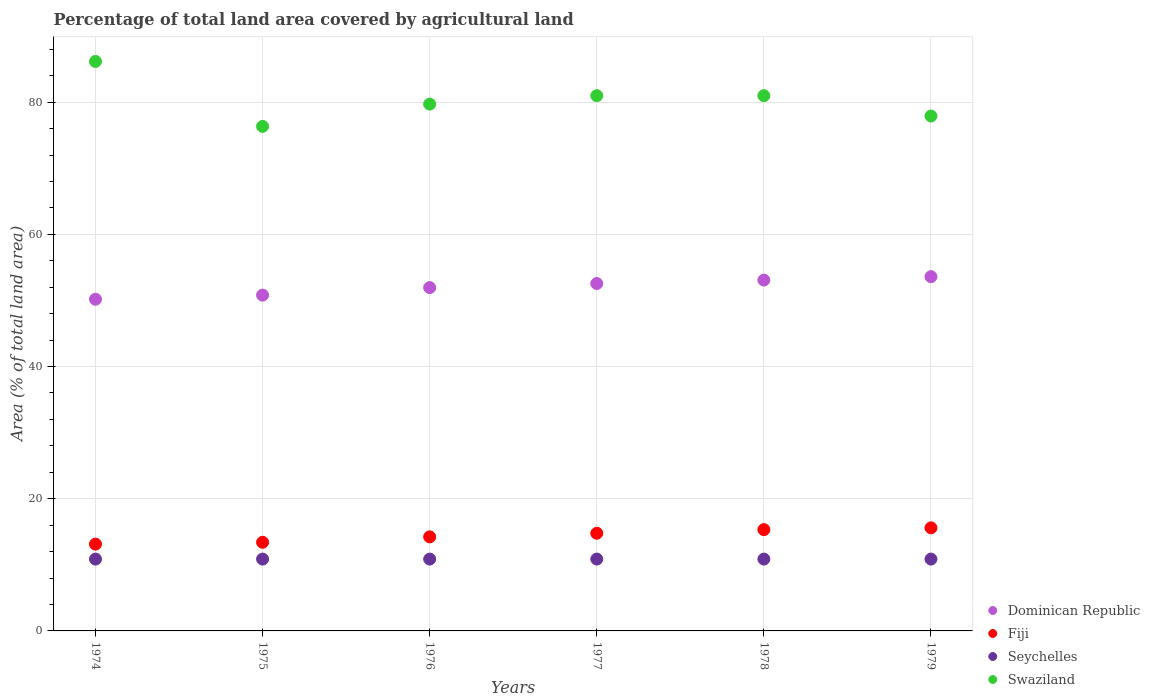How many different coloured dotlines are there?
Ensure brevity in your answer.  4. Is the number of dotlines equal to the number of legend labels?
Give a very brief answer. Yes. What is the percentage of agricultural land in Swaziland in 1976?
Offer a terse response. 79.71. Across all years, what is the maximum percentage of agricultural land in Swaziland?
Provide a short and direct response. 86.16. Across all years, what is the minimum percentage of agricultural land in Swaziland?
Offer a very short reply. 76.34. In which year was the percentage of agricultural land in Dominican Republic maximum?
Offer a very short reply. 1979. In which year was the percentage of agricultural land in Seychelles minimum?
Offer a terse response. 1974. What is the total percentage of agricultural land in Fiji in the graph?
Ensure brevity in your answer.  86.48. What is the difference between the percentage of agricultural land in Swaziland in 1977 and that in 1979?
Provide a succinct answer. 3.08. What is the difference between the percentage of agricultural land in Swaziland in 1974 and the percentage of agricultural land in Seychelles in 1977?
Provide a short and direct response. 75.29. What is the average percentage of agricultural land in Fiji per year?
Give a very brief answer. 14.41. In the year 1977, what is the difference between the percentage of agricultural land in Swaziland and percentage of agricultural land in Fiji?
Make the answer very short. 66.21. In how many years, is the percentage of agricultural land in Seychelles greater than 16 %?
Provide a succinct answer. 0. What is the difference between the highest and the second highest percentage of agricultural land in Swaziland?
Make the answer very short. 5.17. What is the difference between the highest and the lowest percentage of agricultural land in Dominican Republic?
Provide a short and direct response. 3.41. Does the percentage of agricultural land in Fiji monotonically increase over the years?
Ensure brevity in your answer.  Yes. Is the percentage of agricultural land in Seychelles strictly greater than the percentage of agricultural land in Dominican Republic over the years?
Your answer should be compact. No. Is the percentage of agricultural land in Dominican Republic strictly less than the percentage of agricultural land in Fiji over the years?
Keep it short and to the point. No. What is the difference between two consecutive major ticks on the Y-axis?
Your answer should be compact. 20. Are the values on the major ticks of Y-axis written in scientific E-notation?
Give a very brief answer. No. How are the legend labels stacked?
Offer a very short reply. Vertical. What is the title of the graph?
Keep it short and to the point. Percentage of total land area covered by agricultural land. Does "Japan" appear as one of the legend labels in the graph?
Make the answer very short. No. What is the label or title of the X-axis?
Provide a short and direct response. Years. What is the label or title of the Y-axis?
Keep it short and to the point. Area (% of total land area). What is the Area (% of total land area) in Dominican Republic in 1974?
Your response must be concise. 50.19. What is the Area (% of total land area) of Fiji in 1974?
Provide a succinct answer. 13.14. What is the Area (% of total land area) of Seychelles in 1974?
Give a very brief answer. 10.87. What is the Area (% of total land area) of Swaziland in 1974?
Ensure brevity in your answer.  86.16. What is the Area (% of total land area) in Dominican Republic in 1975?
Give a very brief answer. 50.81. What is the Area (% of total land area) of Fiji in 1975?
Offer a very short reply. 13.41. What is the Area (% of total land area) in Seychelles in 1975?
Keep it short and to the point. 10.87. What is the Area (% of total land area) of Swaziland in 1975?
Make the answer very short. 76.34. What is the Area (% of total land area) of Dominican Republic in 1976?
Offer a terse response. 51.95. What is the Area (% of total land area) of Fiji in 1976?
Give a very brief answer. 14.23. What is the Area (% of total land area) of Seychelles in 1976?
Provide a succinct answer. 10.87. What is the Area (% of total land area) in Swaziland in 1976?
Provide a short and direct response. 79.71. What is the Area (% of total land area) in Dominican Republic in 1977?
Ensure brevity in your answer.  52.57. What is the Area (% of total land area) in Fiji in 1977?
Offer a very short reply. 14.78. What is the Area (% of total land area) of Seychelles in 1977?
Offer a terse response. 10.87. What is the Area (% of total land area) in Swaziland in 1977?
Provide a succinct answer. 80.99. What is the Area (% of total land area) of Dominican Republic in 1978?
Provide a succinct answer. 53.08. What is the Area (% of total land area) of Fiji in 1978?
Make the answer very short. 15.33. What is the Area (% of total land area) in Seychelles in 1978?
Your answer should be compact. 10.87. What is the Area (% of total land area) in Swaziland in 1978?
Your answer should be very brief. 80.99. What is the Area (% of total land area) of Dominican Republic in 1979?
Offer a very short reply. 53.6. What is the Area (% of total land area) of Fiji in 1979?
Ensure brevity in your answer.  15.6. What is the Area (% of total land area) of Seychelles in 1979?
Provide a short and direct response. 10.87. What is the Area (% of total land area) in Swaziland in 1979?
Your response must be concise. 77.91. Across all years, what is the maximum Area (% of total land area) in Dominican Republic?
Your answer should be compact. 53.6. Across all years, what is the maximum Area (% of total land area) of Fiji?
Your response must be concise. 15.6. Across all years, what is the maximum Area (% of total land area) in Seychelles?
Ensure brevity in your answer.  10.87. Across all years, what is the maximum Area (% of total land area) of Swaziland?
Offer a very short reply. 86.16. Across all years, what is the minimum Area (% of total land area) in Dominican Republic?
Your answer should be very brief. 50.19. Across all years, what is the minimum Area (% of total land area) in Fiji?
Your answer should be very brief. 13.14. Across all years, what is the minimum Area (% of total land area) of Seychelles?
Provide a short and direct response. 10.87. Across all years, what is the minimum Area (% of total land area) of Swaziland?
Your response must be concise. 76.34. What is the total Area (% of total land area) in Dominican Republic in the graph?
Provide a succinct answer. 312.19. What is the total Area (% of total land area) in Fiji in the graph?
Your response must be concise. 86.48. What is the total Area (% of total land area) of Seychelles in the graph?
Make the answer very short. 65.22. What is the total Area (% of total land area) of Swaziland in the graph?
Offer a very short reply. 482.09. What is the difference between the Area (% of total land area) of Dominican Republic in 1974 and that in 1975?
Your response must be concise. -0.62. What is the difference between the Area (% of total land area) of Fiji in 1974 and that in 1975?
Give a very brief answer. -0.27. What is the difference between the Area (% of total land area) in Swaziland in 1974 and that in 1975?
Offer a very short reply. 9.83. What is the difference between the Area (% of total land area) of Dominican Republic in 1974 and that in 1976?
Offer a terse response. -1.76. What is the difference between the Area (% of total land area) in Fiji in 1974 and that in 1976?
Ensure brevity in your answer.  -1.09. What is the difference between the Area (% of total land area) in Swaziland in 1974 and that in 1976?
Keep it short and to the point. 6.45. What is the difference between the Area (% of total land area) of Dominican Republic in 1974 and that in 1977?
Ensure brevity in your answer.  -2.38. What is the difference between the Area (% of total land area) of Fiji in 1974 and that in 1977?
Make the answer very short. -1.64. What is the difference between the Area (% of total land area) of Seychelles in 1974 and that in 1977?
Your answer should be compact. 0. What is the difference between the Area (% of total land area) in Swaziland in 1974 and that in 1977?
Give a very brief answer. 5.17. What is the difference between the Area (% of total land area) in Dominican Republic in 1974 and that in 1978?
Your response must be concise. -2.9. What is the difference between the Area (% of total land area) of Fiji in 1974 and that in 1978?
Your answer should be compact. -2.19. What is the difference between the Area (% of total land area) in Seychelles in 1974 and that in 1978?
Your answer should be compact. 0. What is the difference between the Area (% of total land area) of Swaziland in 1974 and that in 1978?
Keep it short and to the point. 5.17. What is the difference between the Area (% of total land area) of Dominican Republic in 1974 and that in 1979?
Your answer should be compact. -3.41. What is the difference between the Area (% of total land area) of Fiji in 1974 and that in 1979?
Make the answer very short. -2.46. What is the difference between the Area (% of total land area) of Seychelles in 1974 and that in 1979?
Provide a succinct answer. 0. What is the difference between the Area (% of total land area) of Swaziland in 1974 and that in 1979?
Keep it short and to the point. 8.26. What is the difference between the Area (% of total land area) of Dominican Republic in 1975 and that in 1976?
Ensure brevity in your answer.  -1.14. What is the difference between the Area (% of total land area) in Fiji in 1975 and that in 1976?
Your answer should be compact. -0.82. What is the difference between the Area (% of total land area) in Seychelles in 1975 and that in 1976?
Ensure brevity in your answer.  0. What is the difference between the Area (% of total land area) of Swaziland in 1975 and that in 1976?
Keep it short and to the point. -3.37. What is the difference between the Area (% of total land area) in Dominican Republic in 1975 and that in 1977?
Your response must be concise. -1.76. What is the difference between the Area (% of total land area) of Fiji in 1975 and that in 1977?
Provide a short and direct response. -1.37. What is the difference between the Area (% of total land area) of Swaziland in 1975 and that in 1977?
Give a very brief answer. -4.65. What is the difference between the Area (% of total land area) of Dominican Republic in 1975 and that in 1978?
Make the answer very short. -2.28. What is the difference between the Area (% of total land area) in Fiji in 1975 and that in 1978?
Keep it short and to the point. -1.92. What is the difference between the Area (% of total land area) of Seychelles in 1975 and that in 1978?
Offer a very short reply. 0. What is the difference between the Area (% of total land area) of Swaziland in 1975 and that in 1978?
Your answer should be very brief. -4.65. What is the difference between the Area (% of total land area) of Dominican Republic in 1975 and that in 1979?
Offer a terse response. -2.79. What is the difference between the Area (% of total land area) in Fiji in 1975 and that in 1979?
Keep it short and to the point. -2.19. What is the difference between the Area (% of total land area) in Swaziland in 1975 and that in 1979?
Your answer should be very brief. -1.57. What is the difference between the Area (% of total land area) of Dominican Republic in 1976 and that in 1977?
Your answer should be compact. -0.62. What is the difference between the Area (% of total land area) in Fiji in 1976 and that in 1977?
Make the answer very short. -0.55. What is the difference between the Area (% of total land area) of Swaziland in 1976 and that in 1977?
Your answer should be very brief. -1.28. What is the difference between the Area (% of total land area) of Dominican Republic in 1976 and that in 1978?
Your answer should be compact. -1.14. What is the difference between the Area (% of total land area) in Fiji in 1976 and that in 1978?
Ensure brevity in your answer.  -1.09. What is the difference between the Area (% of total land area) in Seychelles in 1976 and that in 1978?
Make the answer very short. 0. What is the difference between the Area (% of total land area) of Swaziland in 1976 and that in 1978?
Give a very brief answer. -1.28. What is the difference between the Area (% of total land area) of Dominican Republic in 1976 and that in 1979?
Your response must be concise. -1.66. What is the difference between the Area (% of total land area) of Fiji in 1976 and that in 1979?
Your answer should be compact. -1.37. What is the difference between the Area (% of total land area) in Seychelles in 1976 and that in 1979?
Keep it short and to the point. 0. What is the difference between the Area (% of total land area) of Swaziland in 1976 and that in 1979?
Make the answer very short. 1.8. What is the difference between the Area (% of total land area) in Dominican Republic in 1977 and that in 1978?
Provide a succinct answer. -0.52. What is the difference between the Area (% of total land area) in Fiji in 1977 and that in 1978?
Make the answer very short. -0.55. What is the difference between the Area (% of total land area) of Seychelles in 1977 and that in 1978?
Give a very brief answer. 0. What is the difference between the Area (% of total land area) in Dominican Republic in 1977 and that in 1979?
Offer a terse response. -1.03. What is the difference between the Area (% of total land area) in Fiji in 1977 and that in 1979?
Ensure brevity in your answer.  -0.82. What is the difference between the Area (% of total land area) of Swaziland in 1977 and that in 1979?
Provide a short and direct response. 3.08. What is the difference between the Area (% of total land area) in Dominican Republic in 1978 and that in 1979?
Offer a very short reply. -0.52. What is the difference between the Area (% of total land area) of Fiji in 1978 and that in 1979?
Offer a very short reply. -0.27. What is the difference between the Area (% of total land area) in Swaziland in 1978 and that in 1979?
Provide a short and direct response. 3.08. What is the difference between the Area (% of total land area) of Dominican Republic in 1974 and the Area (% of total land area) of Fiji in 1975?
Make the answer very short. 36.78. What is the difference between the Area (% of total land area) in Dominican Republic in 1974 and the Area (% of total land area) in Seychelles in 1975?
Provide a short and direct response. 39.32. What is the difference between the Area (% of total land area) in Dominican Republic in 1974 and the Area (% of total land area) in Swaziland in 1975?
Your answer should be compact. -26.15. What is the difference between the Area (% of total land area) in Fiji in 1974 and the Area (% of total land area) in Seychelles in 1975?
Your response must be concise. 2.27. What is the difference between the Area (% of total land area) in Fiji in 1974 and the Area (% of total land area) in Swaziland in 1975?
Your response must be concise. -63.2. What is the difference between the Area (% of total land area) of Seychelles in 1974 and the Area (% of total land area) of Swaziland in 1975?
Give a very brief answer. -65.47. What is the difference between the Area (% of total land area) in Dominican Republic in 1974 and the Area (% of total land area) in Fiji in 1976?
Ensure brevity in your answer.  35.96. What is the difference between the Area (% of total land area) in Dominican Republic in 1974 and the Area (% of total land area) in Seychelles in 1976?
Offer a terse response. 39.32. What is the difference between the Area (% of total land area) of Dominican Republic in 1974 and the Area (% of total land area) of Swaziland in 1976?
Your answer should be compact. -29.52. What is the difference between the Area (% of total land area) of Fiji in 1974 and the Area (% of total land area) of Seychelles in 1976?
Provide a short and direct response. 2.27. What is the difference between the Area (% of total land area) in Fiji in 1974 and the Area (% of total land area) in Swaziland in 1976?
Offer a terse response. -66.57. What is the difference between the Area (% of total land area) in Seychelles in 1974 and the Area (% of total land area) in Swaziland in 1976?
Ensure brevity in your answer.  -68.84. What is the difference between the Area (% of total land area) of Dominican Republic in 1974 and the Area (% of total land area) of Fiji in 1977?
Your answer should be compact. 35.41. What is the difference between the Area (% of total land area) in Dominican Republic in 1974 and the Area (% of total land area) in Seychelles in 1977?
Ensure brevity in your answer.  39.32. What is the difference between the Area (% of total land area) of Dominican Republic in 1974 and the Area (% of total land area) of Swaziland in 1977?
Make the answer very short. -30.8. What is the difference between the Area (% of total land area) in Fiji in 1974 and the Area (% of total land area) in Seychelles in 1977?
Make the answer very short. 2.27. What is the difference between the Area (% of total land area) of Fiji in 1974 and the Area (% of total land area) of Swaziland in 1977?
Your response must be concise. -67.85. What is the difference between the Area (% of total land area) of Seychelles in 1974 and the Area (% of total land area) of Swaziland in 1977?
Offer a terse response. -70.12. What is the difference between the Area (% of total land area) of Dominican Republic in 1974 and the Area (% of total land area) of Fiji in 1978?
Your answer should be very brief. 34.86. What is the difference between the Area (% of total land area) in Dominican Republic in 1974 and the Area (% of total land area) in Seychelles in 1978?
Ensure brevity in your answer.  39.32. What is the difference between the Area (% of total land area) of Dominican Republic in 1974 and the Area (% of total land area) of Swaziland in 1978?
Offer a terse response. -30.8. What is the difference between the Area (% of total land area) of Fiji in 1974 and the Area (% of total land area) of Seychelles in 1978?
Your response must be concise. 2.27. What is the difference between the Area (% of total land area) in Fiji in 1974 and the Area (% of total land area) in Swaziland in 1978?
Offer a very short reply. -67.85. What is the difference between the Area (% of total land area) in Seychelles in 1974 and the Area (% of total land area) in Swaziland in 1978?
Provide a short and direct response. -70.12. What is the difference between the Area (% of total land area) of Dominican Republic in 1974 and the Area (% of total land area) of Fiji in 1979?
Ensure brevity in your answer.  34.59. What is the difference between the Area (% of total land area) of Dominican Republic in 1974 and the Area (% of total land area) of Seychelles in 1979?
Make the answer very short. 39.32. What is the difference between the Area (% of total land area) in Dominican Republic in 1974 and the Area (% of total land area) in Swaziland in 1979?
Give a very brief answer. -27.72. What is the difference between the Area (% of total land area) of Fiji in 1974 and the Area (% of total land area) of Seychelles in 1979?
Your answer should be compact. 2.27. What is the difference between the Area (% of total land area) in Fiji in 1974 and the Area (% of total land area) in Swaziland in 1979?
Ensure brevity in your answer.  -64.77. What is the difference between the Area (% of total land area) of Seychelles in 1974 and the Area (% of total land area) of Swaziland in 1979?
Your response must be concise. -67.04. What is the difference between the Area (% of total land area) in Dominican Republic in 1975 and the Area (% of total land area) in Fiji in 1976?
Make the answer very short. 36.58. What is the difference between the Area (% of total land area) of Dominican Republic in 1975 and the Area (% of total land area) of Seychelles in 1976?
Give a very brief answer. 39.94. What is the difference between the Area (% of total land area) in Dominican Republic in 1975 and the Area (% of total land area) in Swaziland in 1976?
Your answer should be compact. -28.9. What is the difference between the Area (% of total land area) in Fiji in 1975 and the Area (% of total land area) in Seychelles in 1976?
Offer a terse response. 2.54. What is the difference between the Area (% of total land area) of Fiji in 1975 and the Area (% of total land area) of Swaziland in 1976?
Provide a succinct answer. -66.3. What is the difference between the Area (% of total land area) in Seychelles in 1975 and the Area (% of total land area) in Swaziland in 1976?
Your answer should be compact. -68.84. What is the difference between the Area (% of total land area) of Dominican Republic in 1975 and the Area (% of total land area) of Fiji in 1977?
Ensure brevity in your answer.  36.03. What is the difference between the Area (% of total land area) in Dominican Republic in 1975 and the Area (% of total land area) in Seychelles in 1977?
Your response must be concise. 39.94. What is the difference between the Area (% of total land area) of Dominican Republic in 1975 and the Area (% of total land area) of Swaziland in 1977?
Your answer should be very brief. -30.18. What is the difference between the Area (% of total land area) in Fiji in 1975 and the Area (% of total land area) in Seychelles in 1977?
Ensure brevity in your answer.  2.54. What is the difference between the Area (% of total land area) of Fiji in 1975 and the Area (% of total land area) of Swaziland in 1977?
Offer a very short reply. -67.58. What is the difference between the Area (% of total land area) of Seychelles in 1975 and the Area (% of total land area) of Swaziland in 1977?
Provide a succinct answer. -70.12. What is the difference between the Area (% of total land area) of Dominican Republic in 1975 and the Area (% of total land area) of Fiji in 1978?
Provide a succinct answer. 35.48. What is the difference between the Area (% of total land area) of Dominican Republic in 1975 and the Area (% of total land area) of Seychelles in 1978?
Ensure brevity in your answer.  39.94. What is the difference between the Area (% of total land area) in Dominican Republic in 1975 and the Area (% of total land area) in Swaziland in 1978?
Provide a short and direct response. -30.18. What is the difference between the Area (% of total land area) in Fiji in 1975 and the Area (% of total land area) in Seychelles in 1978?
Provide a short and direct response. 2.54. What is the difference between the Area (% of total land area) in Fiji in 1975 and the Area (% of total land area) in Swaziland in 1978?
Your answer should be very brief. -67.58. What is the difference between the Area (% of total land area) of Seychelles in 1975 and the Area (% of total land area) of Swaziland in 1978?
Offer a very short reply. -70.12. What is the difference between the Area (% of total land area) of Dominican Republic in 1975 and the Area (% of total land area) of Fiji in 1979?
Give a very brief answer. 35.21. What is the difference between the Area (% of total land area) in Dominican Republic in 1975 and the Area (% of total land area) in Seychelles in 1979?
Your answer should be compact. 39.94. What is the difference between the Area (% of total land area) of Dominican Republic in 1975 and the Area (% of total land area) of Swaziland in 1979?
Offer a very short reply. -27.1. What is the difference between the Area (% of total land area) of Fiji in 1975 and the Area (% of total land area) of Seychelles in 1979?
Keep it short and to the point. 2.54. What is the difference between the Area (% of total land area) in Fiji in 1975 and the Area (% of total land area) in Swaziland in 1979?
Provide a short and direct response. -64.5. What is the difference between the Area (% of total land area) in Seychelles in 1975 and the Area (% of total land area) in Swaziland in 1979?
Keep it short and to the point. -67.04. What is the difference between the Area (% of total land area) in Dominican Republic in 1976 and the Area (% of total land area) in Fiji in 1977?
Keep it short and to the point. 37.17. What is the difference between the Area (% of total land area) of Dominican Republic in 1976 and the Area (% of total land area) of Seychelles in 1977?
Your response must be concise. 41.08. What is the difference between the Area (% of total land area) of Dominican Republic in 1976 and the Area (% of total land area) of Swaziland in 1977?
Your answer should be compact. -29.04. What is the difference between the Area (% of total land area) in Fiji in 1976 and the Area (% of total land area) in Seychelles in 1977?
Ensure brevity in your answer.  3.36. What is the difference between the Area (% of total land area) of Fiji in 1976 and the Area (% of total land area) of Swaziland in 1977?
Offer a terse response. -66.76. What is the difference between the Area (% of total land area) in Seychelles in 1976 and the Area (% of total land area) in Swaziland in 1977?
Give a very brief answer. -70.12. What is the difference between the Area (% of total land area) in Dominican Republic in 1976 and the Area (% of total land area) in Fiji in 1978?
Offer a terse response. 36.62. What is the difference between the Area (% of total land area) of Dominican Republic in 1976 and the Area (% of total land area) of Seychelles in 1978?
Provide a succinct answer. 41.08. What is the difference between the Area (% of total land area) in Dominican Republic in 1976 and the Area (% of total land area) in Swaziland in 1978?
Keep it short and to the point. -29.04. What is the difference between the Area (% of total land area) in Fiji in 1976 and the Area (% of total land area) in Seychelles in 1978?
Give a very brief answer. 3.36. What is the difference between the Area (% of total land area) of Fiji in 1976 and the Area (% of total land area) of Swaziland in 1978?
Your answer should be compact. -66.76. What is the difference between the Area (% of total land area) of Seychelles in 1976 and the Area (% of total land area) of Swaziland in 1978?
Your answer should be very brief. -70.12. What is the difference between the Area (% of total land area) of Dominican Republic in 1976 and the Area (% of total land area) of Fiji in 1979?
Your answer should be compact. 36.35. What is the difference between the Area (% of total land area) of Dominican Republic in 1976 and the Area (% of total land area) of Seychelles in 1979?
Offer a very short reply. 41.08. What is the difference between the Area (% of total land area) of Dominican Republic in 1976 and the Area (% of total land area) of Swaziland in 1979?
Your answer should be compact. -25.96. What is the difference between the Area (% of total land area) in Fiji in 1976 and the Area (% of total land area) in Seychelles in 1979?
Give a very brief answer. 3.36. What is the difference between the Area (% of total land area) of Fiji in 1976 and the Area (% of total land area) of Swaziland in 1979?
Keep it short and to the point. -63.68. What is the difference between the Area (% of total land area) in Seychelles in 1976 and the Area (% of total land area) in Swaziland in 1979?
Offer a very short reply. -67.04. What is the difference between the Area (% of total land area) of Dominican Republic in 1977 and the Area (% of total land area) of Fiji in 1978?
Your response must be concise. 37.24. What is the difference between the Area (% of total land area) in Dominican Republic in 1977 and the Area (% of total land area) in Seychelles in 1978?
Provide a succinct answer. 41.7. What is the difference between the Area (% of total land area) of Dominican Republic in 1977 and the Area (% of total land area) of Swaziland in 1978?
Your answer should be compact. -28.42. What is the difference between the Area (% of total land area) in Fiji in 1977 and the Area (% of total land area) in Seychelles in 1978?
Provide a succinct answer. 3.91. What is the difference between the Area (% of total land area) of Fiji in 1977 and the Area (% of total land area) of Swaziland in 1978?
Give a very brief answer. -66.21. What is the difference between the Area (% of total land area) in Seychelles in 1977 and the Area (% of total land area) in Swaziland in 1978?
Make the answer very short. -70.12. What is the difference between the Area (% of total land area) of Dominican Republic in 1977 and the Area (% of total land area) of Fiji in 1979?
Offer a very short reply. 36.97. What is the difference between the Area (% of total land area) of Dominican Republic in 1977 and the Area (% of total land area) of Seychelles in 1979?
Provide a short and direct response. 41.7. What is the difference between the Area (% of total land area) of Dominican Republic in 1977 and the Area (% of total land area) of Swaziland in 1979?
Make the answer very short. -25.34. What is the difference between the Area (% of total land area) in Fiji in 1977 and the Area (% of total land area) in Seychelles in 1979?
Your answer should be compact. 3.91. What is the difference between the Area (% of total land area) of Fiji in 1977 and the Area (% of total land area) of Swaziland in 1979?
Offer a terse response. -63.13. What is the difference between the Area (% of total land area) in Seychelles in 1977 and the Area (% of total land area) in Swaziland in 1979?
Your response must be concise. -67.04. What is the difference between the Area (% of total land area) of Dominican Republic in 1978 and the Area (% of total land area) of Fiji in 1979?
Keep it short and to the point. 37.48. What is the difference between the Area (% of total land area) of Dominican Republic in 1978 and the Area (% of total land area) of Seychelles in 1979?
Provide a succinct answer. 42.21. What is the difference between the Area (% of total land area) in Dominican Republic in 1978 and the Area (% of total land area) in Swaziland in 1979?
Keep it short and to the point. -24.82. What is the difference between the Area (% of total land area) of Fiji in 1978 and the Area (% of total land area) of Seychelles in 1979?
Keep it short and to the point. 4.46. What is the difference between the Area (% of total land area) of Fiji in 1978 and the Area (% of total land area) of Swaziland in 1979?
Your answer should be very brief. -62.58. What is the difference between the Area (% of total land area) in Seychelles in 1978 and the Area (% of total land area) in Swaziland in 1979?
Provide a succinct answer. -67.04. What is the average Area (% of total land area) in Dominican Republic per year?
Offer a terse response. 52.03. What is the average Area (% of total land area) of Fiji per year?
Make the answer very short. 14.41. What is the average Area (% of total land area) of Seychelles per year?
Your answer should be compact. 10.87. What is the average Area (% of total land area) of Swaziland per year?
Make the answer very short. 80.35. In the year 1974, what is the difference between the Area (% of total land area) of Dominican Republic and Area (% of total land area) of Fiji?
Your answer should be compact. 37.05. In the year 1974, what is the difference between the Area (% of total land area) of Dominican Republic and Area (% of total land area) of Seychelles?
Offer a very short reply. 39.32. In the year 1974, what is the difference between the Area (% of total land area) in Dominican Republic and Area (% of total land area) in Swaziland?
Offer a very short reply. -35.98. In the year 1974, what is the difference between the Area (% of total land area) in Fiji and Area (% of total land area) in Seychelles?
Your answer should be very brief. 2.27. In the year 1974, what is the difference between the Area (% of total land area) of Fiji and Area (% of total land area) of Swaziland?
Make the answer very short. -73.03. In the year 1974, what is the difference between the Area (% of total land area) of Seychelles and Area (% of total land area) of Swaziland?
Provide a succinct answer. -75.29. In the year 1975, what is the difference between the Area (% of total land area) of Dominican Republic and Area (% of total land area) of Fiji?
Your answer should be very brief. 37.4. In the year 1975, what is the difference between the Area (% of total land area) in Dominican Republic and Area (% of total land area) in Seychelles?
Make the answer very short. 39.94. In the year 1975, what is the difference between the Area (% of total land area) in Dominican Republic and Area (% of total land area) in Swaziland?
Provide a short and direct response. -25.53. In the year 1975, what is the difference between the Area (% of total land area) in Fiji and Area (% of total land area) in Seychelles?
Your response must be concise. 2.54. In the year 1975, what is the difference between the Area (% of total land area) of Fiji and Area (% of total land area) of Swaziland?
Make the answer very short. -62.93. In the year 1975, what is the difference between the Area (% of total land area) of Seychelles and Area (% of total land area) of Swaziland?
Your response must be concise. -65.47. In the year 1976, what is the difference between the Area (% of total land area) of Dominican Republic and Area (% of total land area) of Fiji?
Your answer should be very brief. 37.71. In the year 1976, what is the difference between the Area (% of total land area) of Dominican Republic and Area (% of total land area) of Seychelles?
Provide a short and direct response. 41.08. In the year 1976, what is the difference between the Area (% of total land area) in Dominican Republic and Area (% of total land area) in Swaziland?
Ensure brevity in your answer.  -27.76. In the year 1976, what is the difference between the Area (% of total land area) of Fiji and Area (% of total land area) of Seychelles?
Your answer should be compact. 3.36. In the year 1976, what is the difference between the Area (% of total land area) in Fiji and Area (% of total land area) in Swaziland?
Your answer should be compact. -65.48. In the year 1976, what is the difference between the Area (% of total land area) in Seychelles and Area (% of total land area) in Swaziland?
Provide a short and direct response. -68.84. In the year 1977, what is the difference between the Area (% of total land area) in Dominican Republic and Area (% of total land area) in Fiji?
Your answer should be compact. 37.79. In the year 1977, what is the difference between the Area (% of total land area) in Dominican Republic and Area (% of total land area) in Seychelles?
Your answer should be very brief. 41.7. In the year 1977, what is the difference between the Area (% of total land area) of Dominican Republic and Area (% of total land area) of Swaziland?
Offer a terse response. -28.42. In the year 1977, what is the difference between the Area (% of total land area) in Fiji and Area (% of total land area) in Seychelles?
Your response must be concise. 3.91. In the year 1977, what is the difference between the Area (% of total land area) of Fiji and Area (% of total land area) of Swaziland?
Offer a very short reply. -66.21. In the year 1977, what is the difference between the Area (% of total land area) in Seychelles and Area (% of total land area) in Swaziland?
Provide a succinct answer. -70.12. In the year 1978, what is the difference between the Area (% of total land area) in Dominican Republic and Area (% of total land area) in Fiji?
Your response must be concise. 37.76. In the year 1978, what is the difference between the Area (% of total land area) in Dominican Republic and Area (% of total land area) in Seychelles?
Provide a short and direct response. 42.21. In the year 1978, what is the difference between the Area (% of total land area) in Dominican Republic and Area (% of total land area) in Swaziland?
Provide a succinct answer. -27.9. In the year 1978, what is the difference between the Area (% of total land area) in Fiji and Area (% of total land area) in Seychelles?
Give a very brief answer. 4.46. In the year 1978, what is the difference between the Area (% of total land area) of Fiji and Area (% of total land area) of Swaziland?
Your response must be concise. -65.66. In the year 1978, what is the difference between the Area (% of total land area) of Seychelles and Area (% of total land area) of Swaziland?
Your response must be concise. -70.12. In the year 1979, what is the difference between the Area (% of total land area) in Dominican Republic and Area (% of total land area) in Fiji?
Ensure brevity in your answer.  38. In the year 1979, what is the difference between the Area (% of total land area) of Dominican Republic and Area (% of total land area) of Seychelles?
Your answer should be compact. 42.73. In the year 1979, what is the difference between the Area (% of total land area) of Dominican Republic and Area (% of total land area) of Swaziland?
Offer a very short reply. -24.31. In the year 1979, what is the difference between the Area (% of total land area) of Fiji and Area (% of total land area) of Seychelles?
Your answer should be compact. 4.73. In the year 1979, what is the difference between the Area (% of total land area) in Fiji and Area (% of total land area) in Swaziland?
Provide a short and direct response. -62.31. In the year 1979, what is the difference between the Area (% of total land area) of Seychelles and Area (% of total land area) of Swaziland?
Provide a short and direct response. -67.04. What is the ratio of the Area (% of total land area) in Dominican Republic in 1974 to that in 1975?
Your answer should be very brief. 0.99. What is the ratio of the Area (% of total land area) of Fiji in 1974 to that in 1975?
Your answer should be very brief. 0.98. What is the ratio of the Area (% of total land area) in Seychelles in 1974 to that in 1975?
Provide a succinct answer. 1. What is the ratio of the Area (% of total land area) in Swaziland in 1974 to that in 1975?
Provide a short and direct response. 1.13. What is the ratio of the Area (% of total land area) of Dominican Republic in 1974 to that in 1976?
Provide a succinct answer. 0.97. What is the ratio of the Area (% of total land area) of Fiji in 1974 to that in 1976?
Offer a terse response. 0.92. What is the ratio of the Area (% of total land area) of Swaziland in 1974 to that in 1976?
Ensure brevity in your answer.  1.08. What is the ratio of the Area (% of total land area) in Dominican Republic in 1974 to that in 1977?
Offer a very short reply. 0.95. What is the ratio of the Area (% of total land area) of Swaziland in 1974 to that in 1977?
Your response must be concise. 1.06. What is the ratio of the Area (% of total land area) in Dominican Republic in 1974 to that in 1978?
Offer a very short reply. 0.95. What is the ratio of the Area (% of total land area) in Swaziland in 1974 to that in 1978?
Your answer should be very brief. 1.06. What is the ratio of the Area (% of total land area) of Dominican Republic in 1974 to that in 1979?
Offer a terse response. 0.94. What is the ratio of the Area (% of total land area) in Fiji in 1974 to that in 1979?
Keep it short and to the point. 0.84. What is the ratio of the Area (% of total land area) of Seychelles in 1974 to that in 1979?
Offer a terse response. 1. What is the ratio of the Area (% of total land area) in Swaziland in 1974 to that in 1979?
Offer a terse response. 1.11. What is the ratio of the Area (% of total land area) in Dominican Republic in 1975 to that in 1976?
Provide a short and direct response. 0.98. What is the ratio of the Area (% of total land area) in Fiji in 1975 to that in 1976?
Provide a short and direct response. 0.94. What is the ratio of the Area (% of total land area) of Seychelles in 1975 to that in 1976?
Keep it short and to the point. 1. What is the ratio of the Area (% of total land area) of Swaziland in 1975 to that in 1976?
Your answer should be compact. 0.96. What is the ratio of the Area (% of total land area) in Dominican Republic in 1975 to that in 1977?
Your response must be concise. 0.97. What is the ratio of the Area (% of total land area) in Fiji in 1975 to that in 1977?
Your response must be concise. 0.91. What is the ratio of the Area (% of total land area) of Swaziland in 1975 to that in 1977?
Provide a short and direct response. 0.94. What is the ratio of the Area (% of total land area) of Dominican Republic in 1975 to that in 1978?
Your answer should be compact. 0.96. What is the ratio of the Area (% of total land area) of Fiji in 1975 to that in 1978?
Provide a short and direct response. 0.88. What is the ratio of the Area (% of total land area) in Seychelles in 1975 to that in 1978?
Ensure brevity in your answer.  1. What is the ratio of the Area (% of total land area) in Swaziland in 1975 to that in 1978?
Make the answer very short. 0.94. What is the ratio of the Area (% of total land area) of Dominican Republic in 1975 to that in 1979?
Ensure brevity in your answer.  0.95. What is the ratio of the Area (% of total land area) in Fiji in 1975 to that in 1979?
Keep it short and to the point. 0.86. What is the ratio of the Area (% of total land area) of Seychelles in 1975 to that in 1979?
Ensure brevity in your answer.  1. What is the ratio of the Area (% of total land area) in Swaziland in 1975 to that in 1979?
Give a very brief answer. 0.98. What is the ratio of the Area (% of total land area) of Dominican Republic in 1976 to that in 1977?
Make the answer very short. 0.99. What is the ratio of the Area (% of total land area) in Fiji in 1976 to that in 1977?
Your answer should be compact. 0.96. What is the ratio of the Area (% of total land area) of Seychelles in 1976 to that in 1977?
Ensure brevity in your answer.  1. What is the ratio of the Area (% of total land area) of Swaziland in 1976 to that in 1977?
Your answer should be very brief. 0.98. What is the ratio of the Area (% of total land area) in Dominican Republic in 1976 to that in 1978?
Provide a succinct answer. 0.98. What is the ratio of the Area (% of total land area) in Swaziland in 1976 to that in 1978?
Provide a succinct answer. 0.98. What is the ratio of the Area (% of total land area) in Dominican Republic in 1976 to that in 1979?
Offer a terse response. 0.97. What is the ratio of the Area (% of total land area) of Fiji in 1976 to that in 1979?
Ensure brevity in your answer.  0.91. What is the ratio of the Area (% of total land area) of Swaziland in 1976 to that in 1979?
Offer a very short reply. 1.02. What is the ratio of the Area (% of total land area) in Dominican Republic in 1977 to that in 1978?
Provide a short and direct response. 0.99. What is the ratio of the Area (% of total land area) of Fiji in 1977 to that in 1978?
Your answer should be compact. 0.96. What is the ratio of the Area (% of total land area) of Seychelles in 1977 to that in 1978?
Offer a terse response. 1. What is the ratio of the Area (% of total land area) in Dominican Republic in 1977 to that in 1979?
Your answer should be very brief. 0.98. What is the ratio of the Area (% of total land area) of Swaziland in 1977 to that in 1979?
Give a very brief answer. 1.04. What is the ratio of the Area (% of total land area) of Dominican Republic in 1978 to that in 1979?
Give a very brief answer. 0.99. What is the ratio of the Area (% of total land area) in Fiji in 1978 to that in 1979?
Provide a succinct answer. 0.98. What is the ratio of the Area (% of total land area) in Swaziland in 1978 to that in 1979?
Offer a very short reply. 1.04. What is the difference between the highest and the second highest Area (% of total land area) of Dominican Republic?
Your response must be concise. 0.52. What is the difference between the highest and the second highest Area (% of total land area) of Fiji?
Your answer should be compact. 0.27. What is the difference between the highest and the second highest Area (% of total land area) of Swaziland?
Make the answer very short. 5.17. What is the difference between the highest and the lowest Area (% of total land area) of Dominican Republic?
Ensure brevity in your answer.  3.41. What is the difference between the highest and the lowest Area (% of total land area) in Fiji?
Make the answer very short. 2.46. What is the difference between the highest and the lowest Area (% of total land area) in Seychelles?
Provide a short and direct response. 0. What is the difference between the highest and the lowest Area (% of total land area) of Swaziland?
Your answer should be very brief. 9.83. 